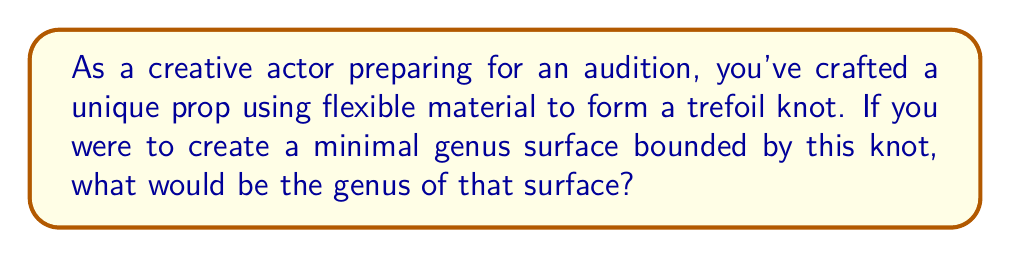Help me with this question. Let's approach this step-by-step:

1) First, recall that the genus of a knot is defined as the minimum genus of any Seifert surface for the knot.

2) For a trefoil knot, we can construct a Seifert surface by the following method:
   a) Start with a disk
   b) Add three half-twisted bands to the disk, connecting it to itself

3) This surface can be visualized as follows:

   [asy]
   import geometry;

   size(200);
   
   path p = circle((0,0),1);
   draw(p);
   
   for(int i=0; i<3; ++i) {
     pair A = dir(120*i);
     pair B = dir(120*i+120);
     draw(A--B);
     draw(A--B, dashed);
   }
   [/asy]

4) To calculate the genus of this surface, we can use the formula:

   $$ g = \frac{1-\chi}{2} $$

   where $g$ is the genus and $\chi$ is the Euler characteristic.

5) The Euler characteristic is given by:

   $$ \chi = V - E + F $$

   where $V$ is the number of vertices, $E$ is the number of edges, and $F$ is the number of faces.

6) For our surface:
   - We have 1 vertex (where the three bands meet)
   - We have 3 edges (the three bands)
   - We have 2 faces (the original disk and the "back" of the surface)

7) Therefore:

   $$ \chi = 1 - 3 + 2 = 0 $$

8) Plugging this into our genus formula:

   $$ g = \frac{1-0}{2} = \frac{1}{2} $$

9) Since the genus must be a non-negative integer, the minimal genus surface for a trefoil knot has genus 1.
Answer: 1 